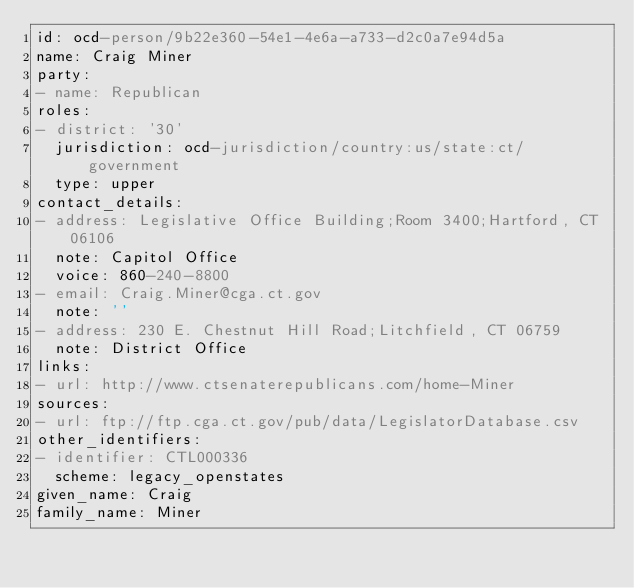<code> <loc_0><loc_0><loc_500><loc_500><_YAML_>id: ocd-person/9b22e360-54e1-4e6a-a733-d2c0a7e94d5a
name: Craig Miner
party:
- name: Republican
roles:
- district: '30'
  jurisdiction: ocd-jurisdiction/country:us/state:ct/government
  type: upper
contact_details:
- address: Legislative Office Building;Room 3400;Hartford, CT 06106
  note: Capitol Office
  voice: 860-240-8800
- email: Craig.Miner@cga.ct.gov
  note: ''
- address: 230 E. Chestnut Hill Road;Litchfield, CT 06759
  note: District Office
links:
- url: http://www.ctsenaterepublicans.com/home-Miner
sources:
- url: ftp://ftp.cga.ct.gov/pub/data/LegislatorDatabase.csv
other_identifiers:
- identifier: CTL000336
  scheme: legacy_openstates
given_name: Craig
family_name: Miner
</code> 